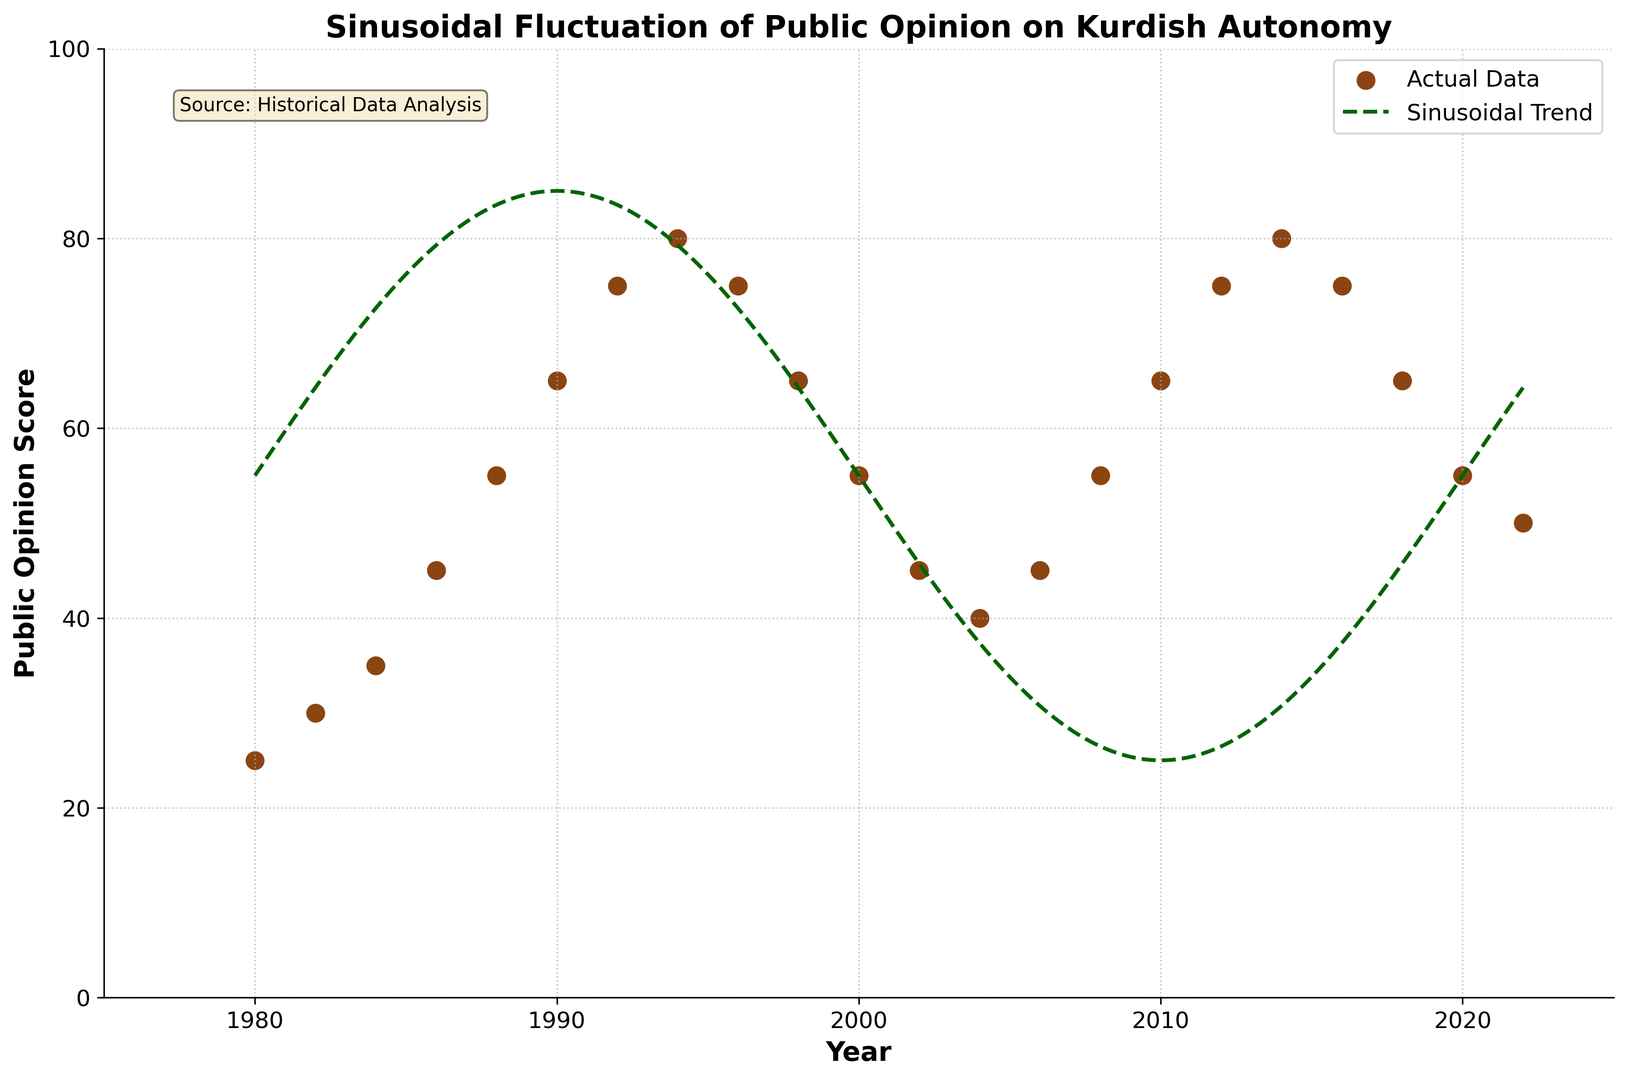What is the public opinion score in the year 1984? Look at the data points on the figure and find the year 1984 on the x-axis. The corresponding public opinion score is shown at the point intersecting with 1984 on the x-axis.
Answer: 35 In which year did the public opinion score peak? Identify the highest point on the y-axis and find the corresponding year on the x-axis. The peak public opinion score, marked with a data point near the top, occurs in 1994 and 2014.
Answer: 1994, 2014 How does the public opinion score in 2002 compare to the score in 2010? Locate the data points for the years 2002 and 2010 on the plot. Compare their heights to see that the score in 2002 is lower than in 2010. The scores are 45 and 65, respectively.
Answer: Lower What is the general trend of public opinion from 1980 to 1994? Observe the data points from 1980 to 1994 on the figure. Note that the opinion score increases steadily from 25 in 1980 to 80 in 1994.
Answer: Increasing By how much did the public opinion score change from 1994 to 2004? Identify the scores for 1994 (80) and 2004 (40). Calculate the difference between these values: 80 - 40 = 40. So, the score decreased by 40 points.
Answer: 40 Which two consecutive years display the greatest difference in public opinion scores? Examine the differences between the public opinion scores of consecutive years. The largest change is from 1992 (75) to 1994 (80) and 1994 (80) to 1996 (75), both a change of 5 points, however among the given data this change has to be closest to 1994 and 1996.
Answer: 1994, 1996 What color is used to represent the actual data points on the plot? Observe the color used for the data points which are round markers on the figure. The color used is a shade of brown.
Answer: Brown Describe the visual difference between the sinusoidal trend line and the actual data points. The actual data points are depicted as circular markers, whereas the sinusoidal trend line is displayed as a green dashed line that smoothly oscillates across the plotted years.
Answer: Circular markers vs. Green dashed line 